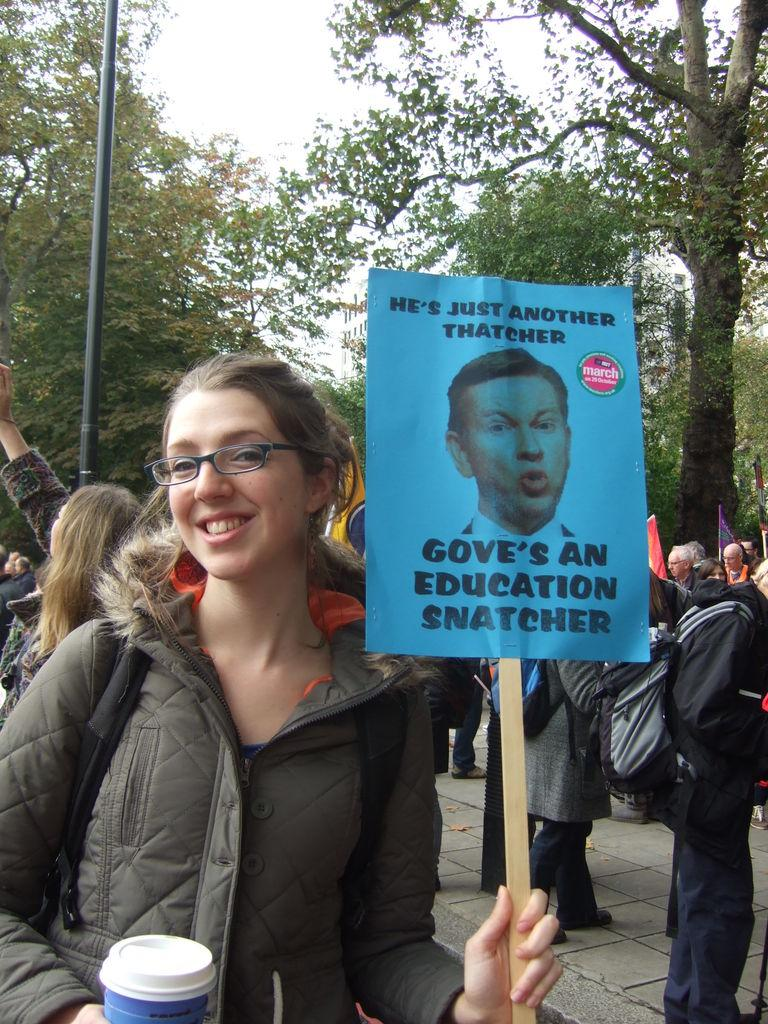Who is the main subject in the image? There is a lady in the image. What is the lady holding in the image? The lady is holding a pamphlet. Can you describe the people behind the lady? There are people visible behind the lady. What can be seen in the background of the image? There is a rod and trees in the background of the image. What type of corn is growing near the rod in the image? There is no corn present in the image; it only features a lady holding a pamphlet, people in the background, and a rod and trees in the background. 